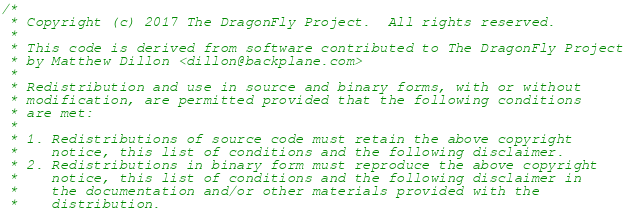Convert code to text. <code><loc_0><loc_0><loc_500><loc_500><_C_>/*
 * Copyright (c) 2017 The DragonFly Project.  All rights reserved.
 *
 * This code is derived from software contributed to The DragonFly Project
 * by Matthew Dillon <dillon@backplane.com>
 *
 * Redistribution and use in source and binary forms, with or without
 * modification, are permitted provided that the following conditions
 * are met:
 *
 * 1. Redistributions of source code must retain the above copyright
 *    notice, this list of conditions and the following disclaimer.
 * 2. Redistributions in binary form must reproduce the above copyright
 *    notice, this list of conditions and the following disclaimer in
 *    the documentation and/or other materials provided with the
 *    distribution.</code> 